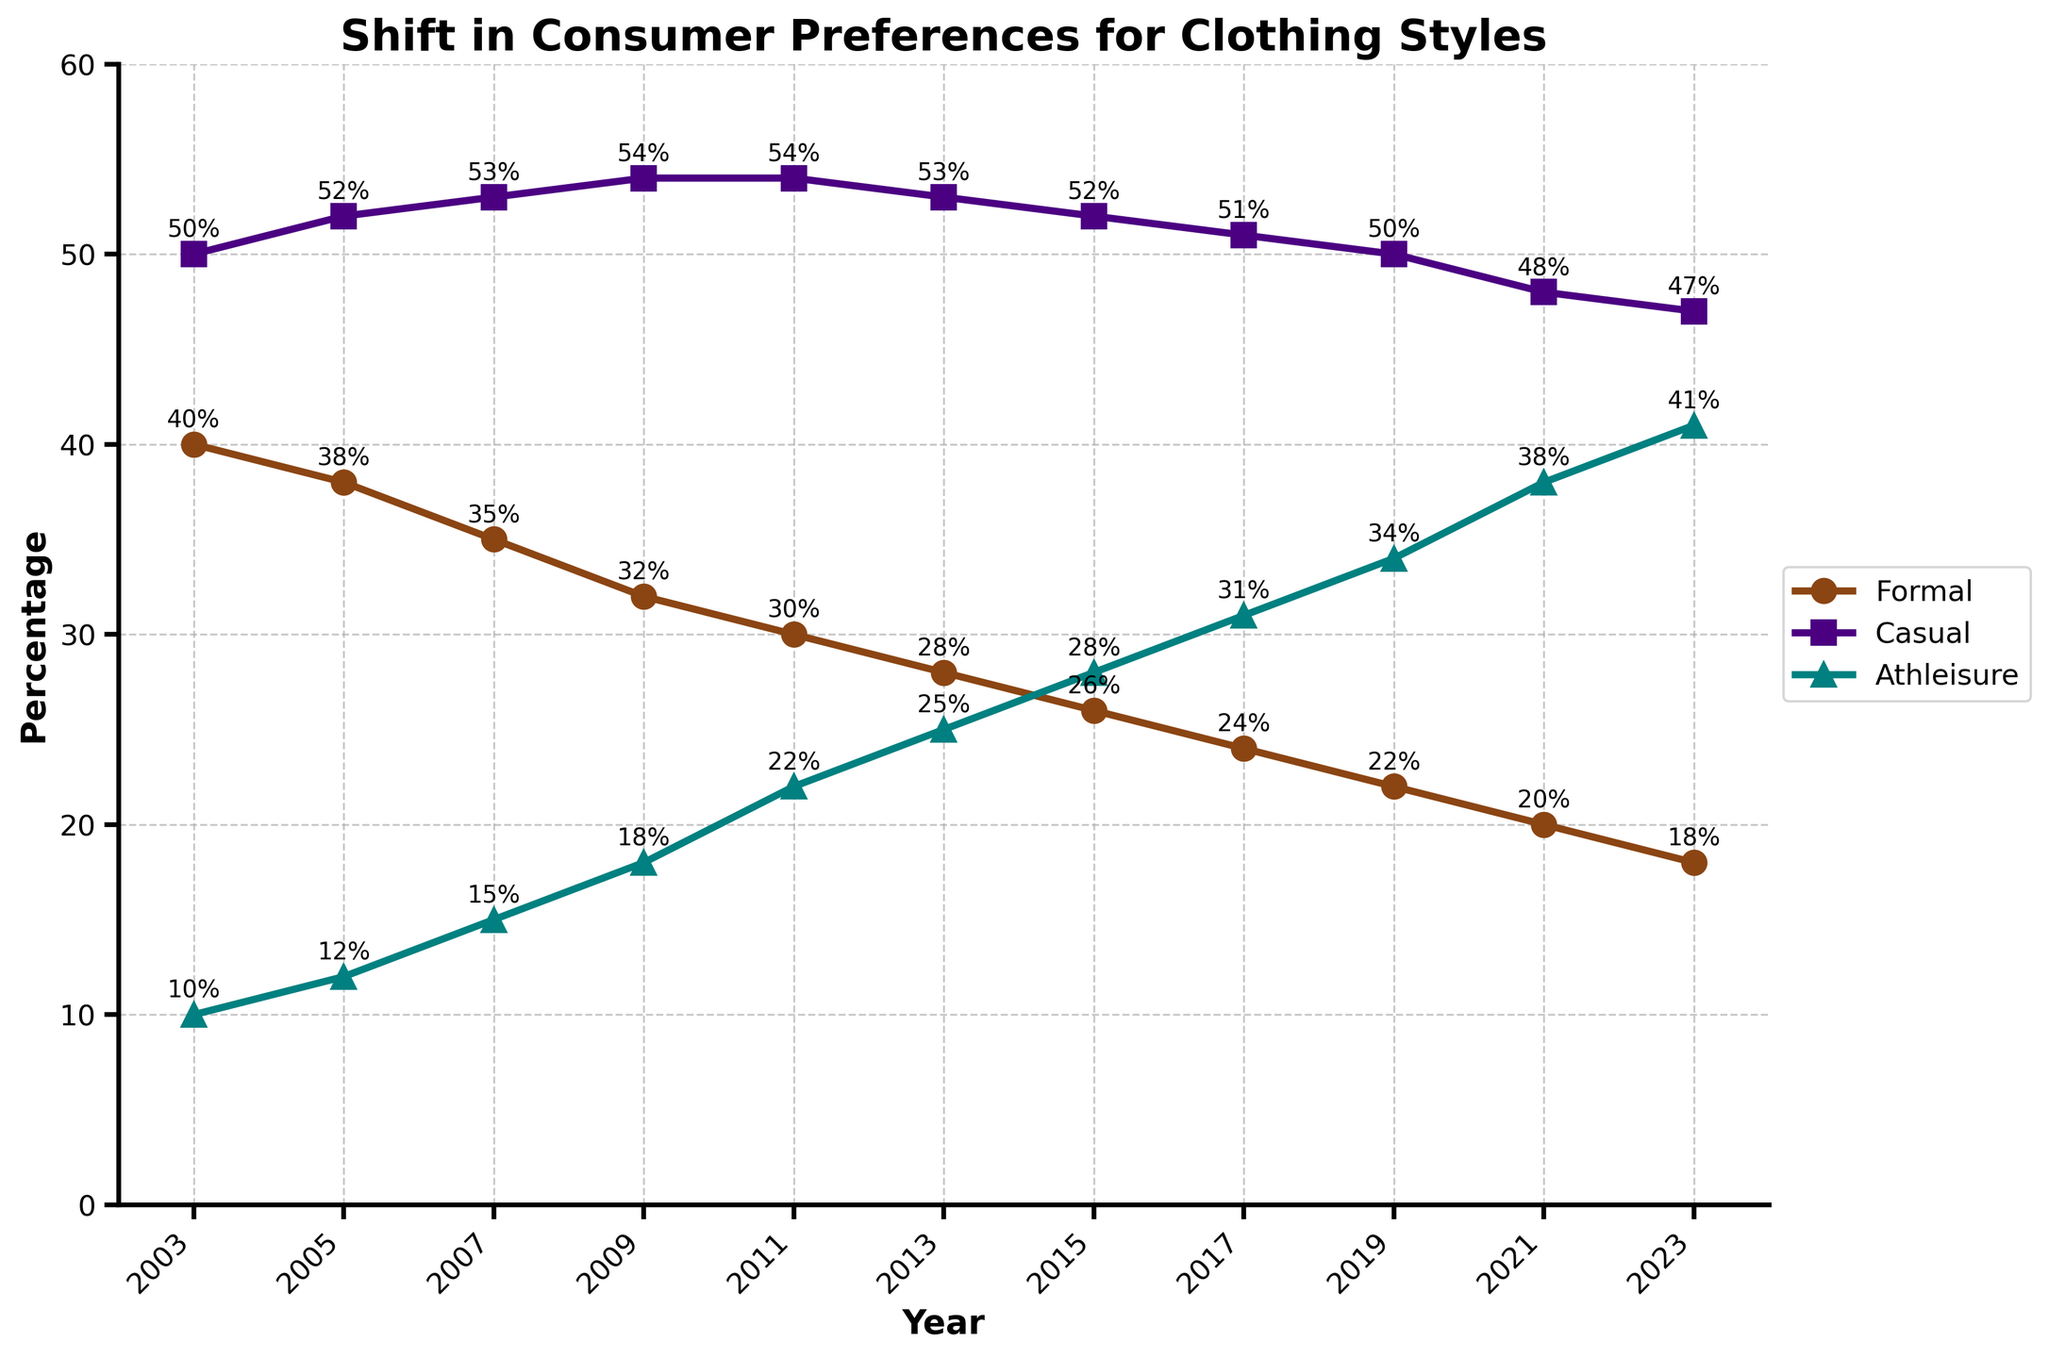what was the percentage change in Formal wear from 2003 to 2023? To find the percentage change, subtract the final value (18%) from the initial value (40%). Then, divide by the initial value (40%) and multiply by 100 to get the percentage change: ((18 - 40) / 40) * 100 = -55%
Answer: -55% In which year did Casual wear have the highest percentage? By examining the line chart, Casual wear had the highest percentage in 2011 with a percentage of 54%.
Answer: 2011 How has the preference for Athleisure changed over the last 20 years? Observing the trend for Athleisure from 2003 to 2023, the percentage increased from 10% to 41%, indicating a rise in preference for Athleisure.
Answer: Increased Compare the trends between Formal and Athleisure wear from 2003 to 2023. Formal wear shows a consistent decrease from 40% to 18%, while Athleisure wear shows a consistent increase from 10% to 41% over the same period.
Answer: Formal decreased, Athleisure increased If you combine the percentages of Formal and Athleisure wear in 2017, what would be the cumulative percentage? Sum the percentages of Formal (24%) and Athleisure (31%) in 2017, resulting in a cumulative percentage of 24 + 31 = 55%.
Answer: 55% How many times did the percentage for Formal wear change by more than 3% between consecutive years? Counting the changes in percentage, observing the differences between consecutive years for Formal wear, confirms two instances of greater than 3% change: 2003-2005 and 2007-2009.
Answer: 2 What was the average percentage preference for Casual wear over the period of 20 years? To find the average, sum up the percentages for Casual wear across all years: 50 + 52 + 53 + 54 + 54 + 53 + 52 + 51 + 50 + 48 + 47 = 564, then divide by the number of years (11): 564 / 11 ≈ 51.27%.
Answer: 51.27% What’s the difference in the percentage points between Athleisure and Formal wear in 2023? Subtract the percentage of Formal wear (18%) from Athleisure (41%) in 2023, resulting in a difference of 41 - 18 = 23 percentage points.
Answer: 23 Which clothing style experienced the steepest increase between any two consecutive years, and in which years? The steepest increase observed is for Athleisure between 2009 (18%) and 2011 (22%), with a difference of 22 - 18 = 4 percentage points.
Answer: Athleisure, 2009-2011 